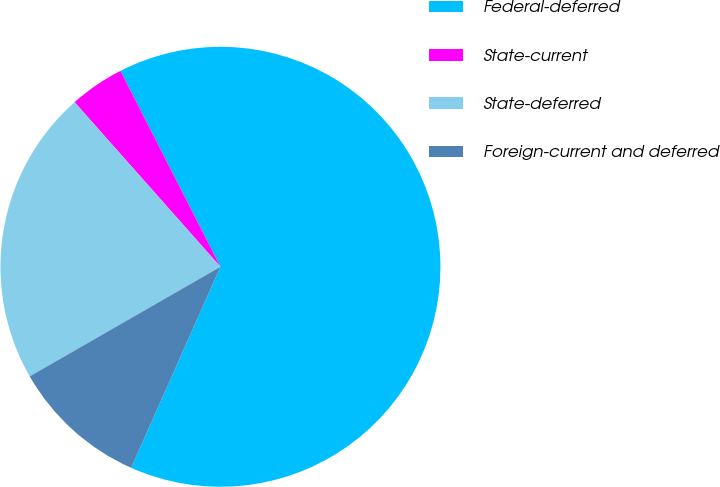Convert chart to OTSL. <chart><loc_0><loc_0><loc_500><loc_500><pie_chart><fcel>Federal-deferred<fcel>State-current<fcel>State-deferred<fcel>Foreign-current and deferred<nl><fcel>64.16%<fcel>4.03%<fcel>21.76%<fcel>10.05%<nl></chart> 